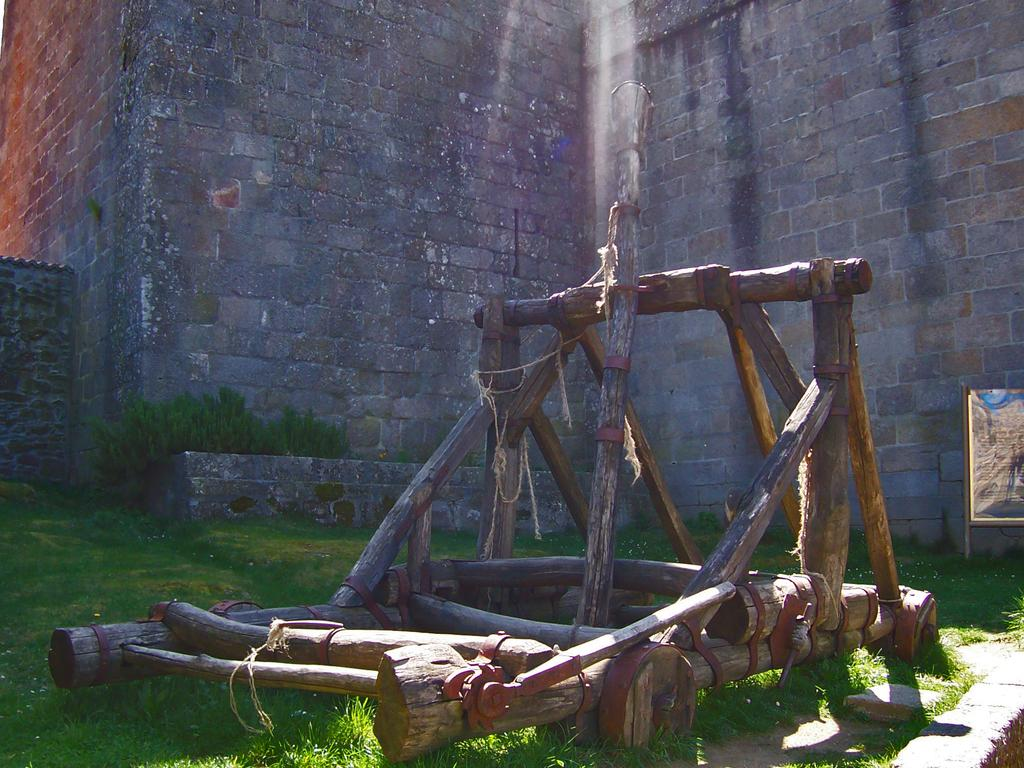What is located in the middle of the image? There are wooden barks in the middle of the image. What can be seen in the background of the image? There are plants and grass in the background of the image. What other object is present in the background of the image? There is a board in the background of the image. What type of soup is being served on the cushion in the image? There is no soup or cushion present in the image. 